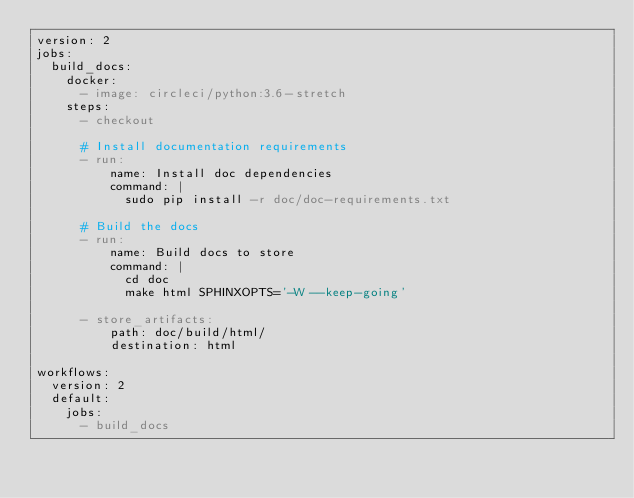Convert code to text. <code><loc_0><loc_0><loc_500><loc_500><_YAML_>version: 2
jobs:
  build_docs:
    docker:
      - image: circleci/python:3.6-stretch
    steps:
      - checkout

      # Install documentation requirements
      - run:
          name: Install doc dependencies
          command: |
            sudo pip install -r doc/doc-requirements.txt

      # Build the docs
      - run:
          name: Build docs to store
          command: |
            cd doc
            make html SPHINXOPTS='-W --keep-going'

      - store_artifacts:
          path: doc/build/html/
          destination: html

workflows:
  version: 2
  default:
    jobs:
      - build_docs
</code> 